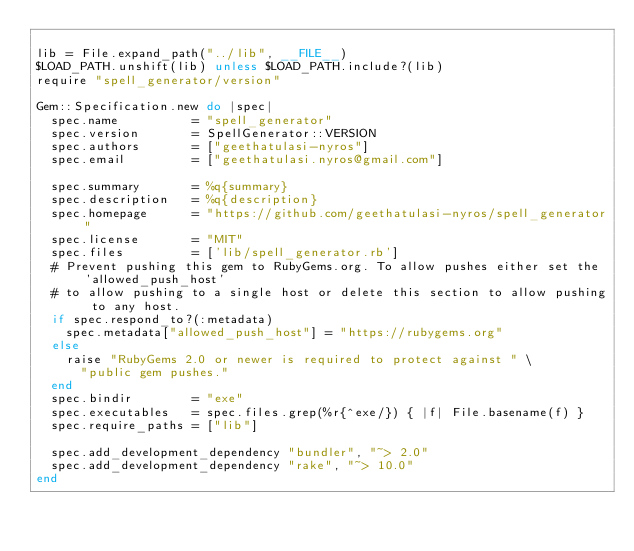Convert code to text. <code><loc_0><loc_0><loc_500><loc_500><_Ruby_>
lib = File.expand_path("../lib", __FILE__)
$LOAD_PATH.unshift(lib) unless $LOAD_PATH.include?(lib)
require "spell_generator/version"

Gem::Specification.new do |spec|
  spec.name          = "spell_generator"
  spec.version       = SpellGenerator::VERSION
  spec.authors       = ["geethatulasi-nyros"]
  spec.email         = ["geethatulasi.nyros@gmail.com"]

  spec.summary       = %q{summary}
  spec.description   = %q{description}
  spec.homepage      = "https://github.com/geethatulasi-nyros/spell_generator"
  spec.license       = "MIT"
  spec.files         = ['lib/spell_generator.rb']
  # Prevent pushing this gem to RubyGems.org. To allow pushes either set the 'allowed_push_host'
  # to allow pushing to a single host or delete this section to allow pushing to any host.
  if spec.respond_to?(:metadata)
    spec.metadata["allowed_push_host"] = "https://rubygems.org"
  else
    raise "RubyGems 2.0 or newer is required to protect against " \
      "public gem pushes."
  end
  spec.bindir        = "exe"
  spec.executables   = spec.files.grep(%r{^exe/}) { |f| File.basename(f) }
  spec.require_paths = ["lib"]

  spec.add_development_dependency "bundler", "~> 2.0"
  spec.add_development_dependency "rake", "~> 10.0"
end
</code> 